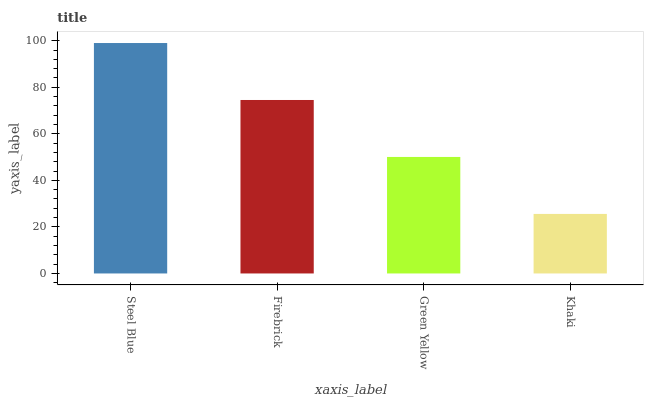Is Firebrick the minimum?
Answer yes or no. No. Is Firebrick the maximum?
Answer yes or no. No. Is Steel Blue greater than Firebrick?
Answer yes or no. Yes. Is Firebrick less than Steel Blue?
Answer yes or no. Yes. Is Firebrick greater than Steel Blue?
Answer yes or no. No. Is Steel Blue less than Firebrick?
Answer yes or no. No. Is Firebrick the high median?
Answer yes or no. Yes. Is Green Yellow the low median?
Answer yes or no. Yes. Is Khaki the high median?
Answer yes or no. No. Is Steel Blue the low median?
Answer yes or no. No. 